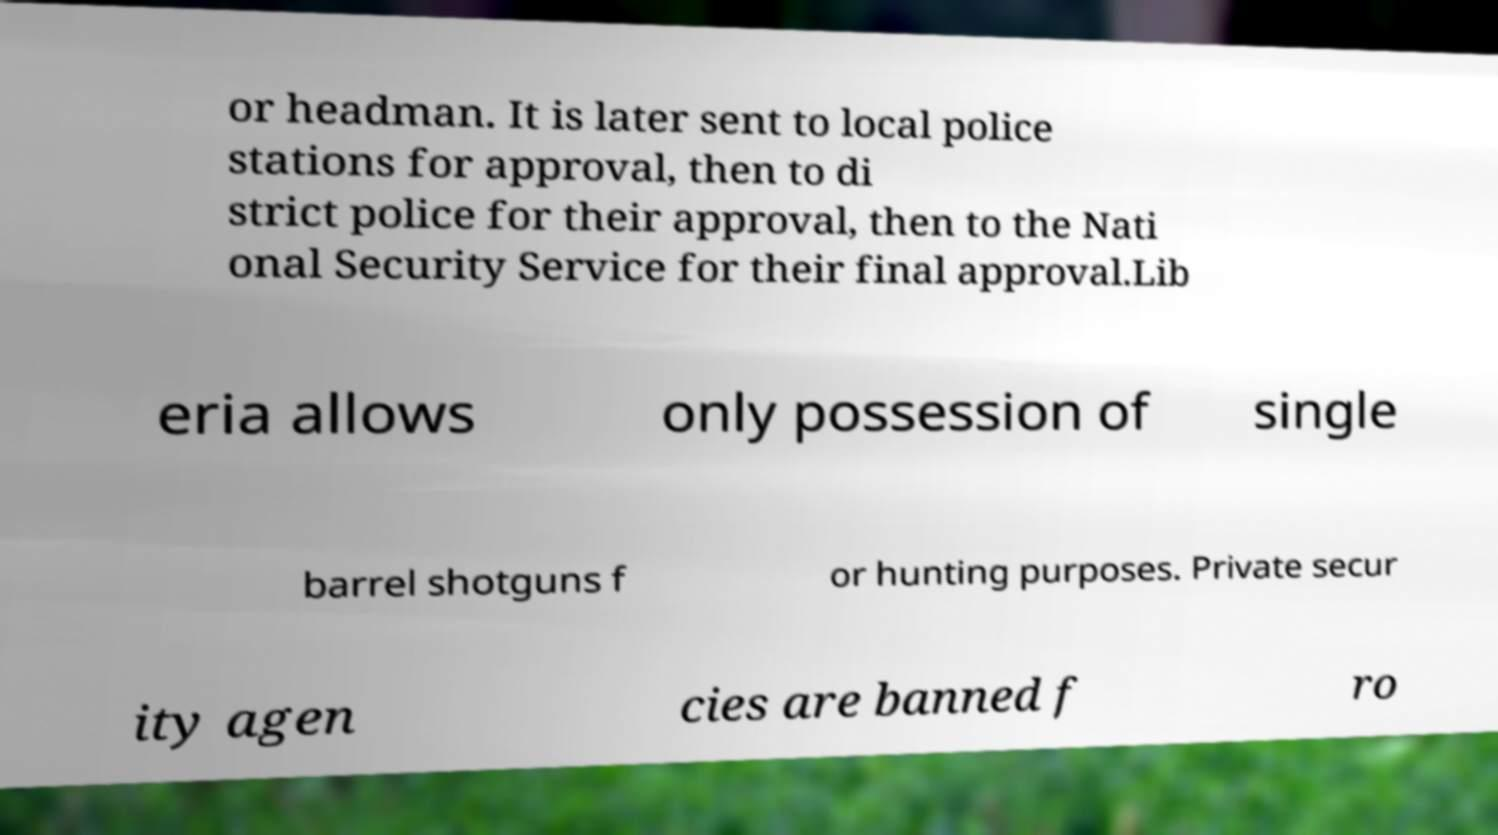What messages or text are displayed in this image? I need them in a readable, typed format. or headman. It is later sent to local police stations for approval, then to di strict police for their approval, then to the Nati onal Security Service for their final approval.Lib eria allows only possession of single barrel shotguns f or hunting purposes. Private secur ity agen cies are banned f ro 